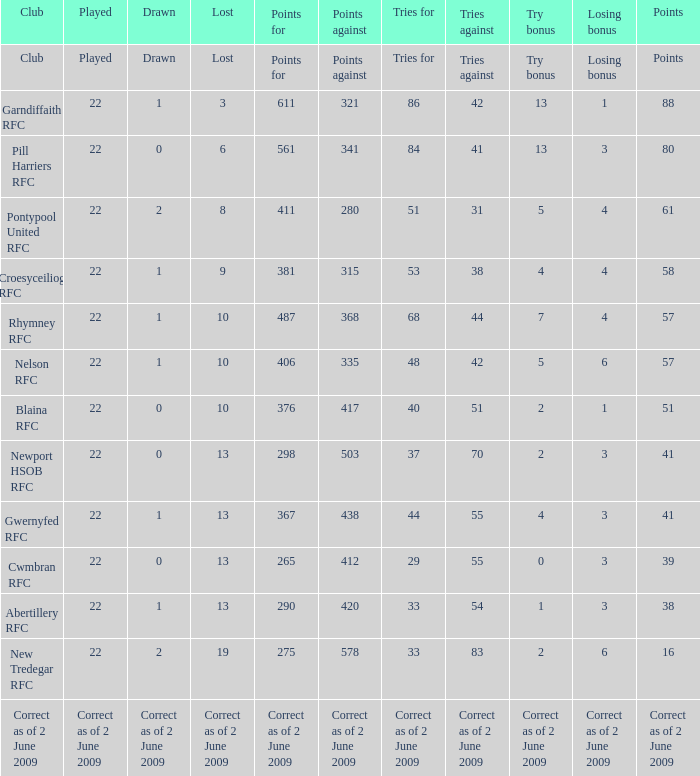Could you help me parse every detail presented in this table? {'header': ['Club', 'Played', 'Drawn', 'Lost', 'Points for', 'Points against', 'Tries for', 'Tries against', 'Try bonus', 'Losing bonus', 'Points'], 'rows': [['Club', 'Played', 'Drawn', 'Lost', 'Points for', 'Points against', 'Tries for', 'Tries against', 'Try bonus', 'Losing bonus', 'Points'], ['Garndiffaith RFC', '22', '1', '3', '611', '321', '86', '42', '13', '1', '88'], ['Pill Harriers RFC', '22', '0', '6', '561', '341', '84', '41', '13', '3', '80'], ['Pontypool United RFC', '22', '2', '8', '411', '280', '51', '31', '5', '4', '61'], ['Croesyceiliog RFC', '22', '1', '9', '381', '315', '53', '38', '4', '4', '58'], ['Rhymney RFC', '22', '1', '10', '487', '368', '68', '44', '7', '4', '57'], ['Nelson RFC', '22', '1', '10', '406', '335', '48', '42', '5', '6', '57'], ['Blaina RFC', '22', '0', '10', '376', '417', '40', '51', '2', '1', '51'], ['Newport HSOB RFC', '22', '0', '13', '298', '503', '37', '70', '2', '3', '41'], ['Gwernyfed RFC', '22', '1', '13', '367', '438', '44', '55', '4', '3', '41'], ['Cwmbran RFC', '22', '0', '13', '265', '412', '29', '55', '0', '3', '39'], ['Abertillery RFC', '22', '1', '13', '290', '420', '33', '54', '1', '3', '38'], ['New Tredegar RFC', '22', '2', '19', '275', '578', '33', '83', '2', '6', '16'], ['Correct as of 2 June 2009', 'Correct as of 2 June 2009', 'Correct as of 2 June 2009', 'Correct as of 2 June 2009', 'Correct as of 2 June 2009', 'Correct as of 2 June 2009', 'Correct as of 2 June 2009', 'Correct as of 2 June 2009', 'Correct as of 2 June 2009', 'Correct as of 2 June 2009', 'Correct as of 2 June 2009']]} How many tries did the club with a try bonus of correct as of 2 June 2009 have? Correct as of 2 June 2009. 